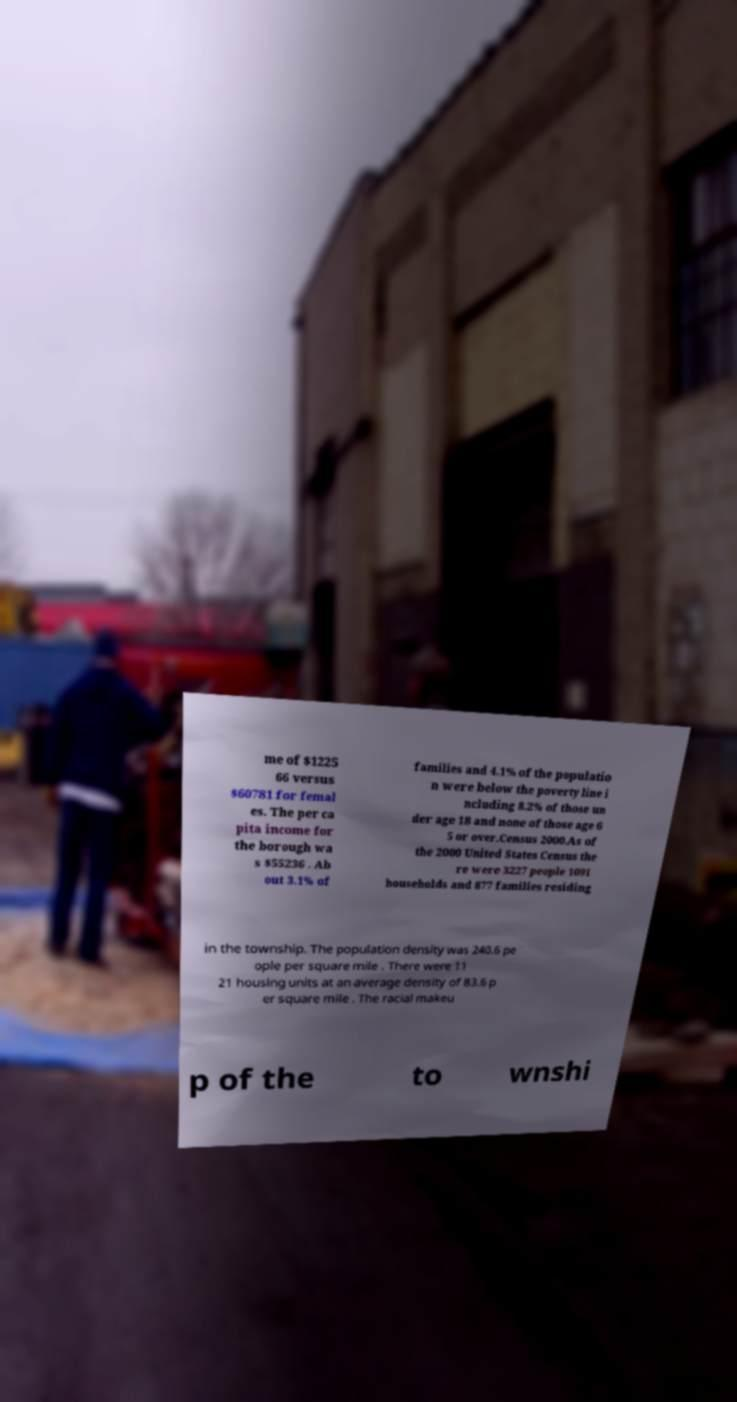Can you read and provide the text displayed in the image?This photo seems to have some interesting text. Can you extract and type it out for me? me of $1225 66 versus $60781 for femal es. The per ca pita income for the borough wa s $55236 . Ab out 3.1% of families and 4.1% of the populatio n were below the poverty line i ncluding 8.2% of those un der age 18 and none of those age 6 5 or over.Census 2000.As of the 2000 United States Census the re were 3227 people 1091 households and 877 families residing in the township. The population density was 240.6 pe ople per square mile . There were 11 21 housing units at an average density of 83.6 p er square mile . The racial makeu p of the to wnshi 